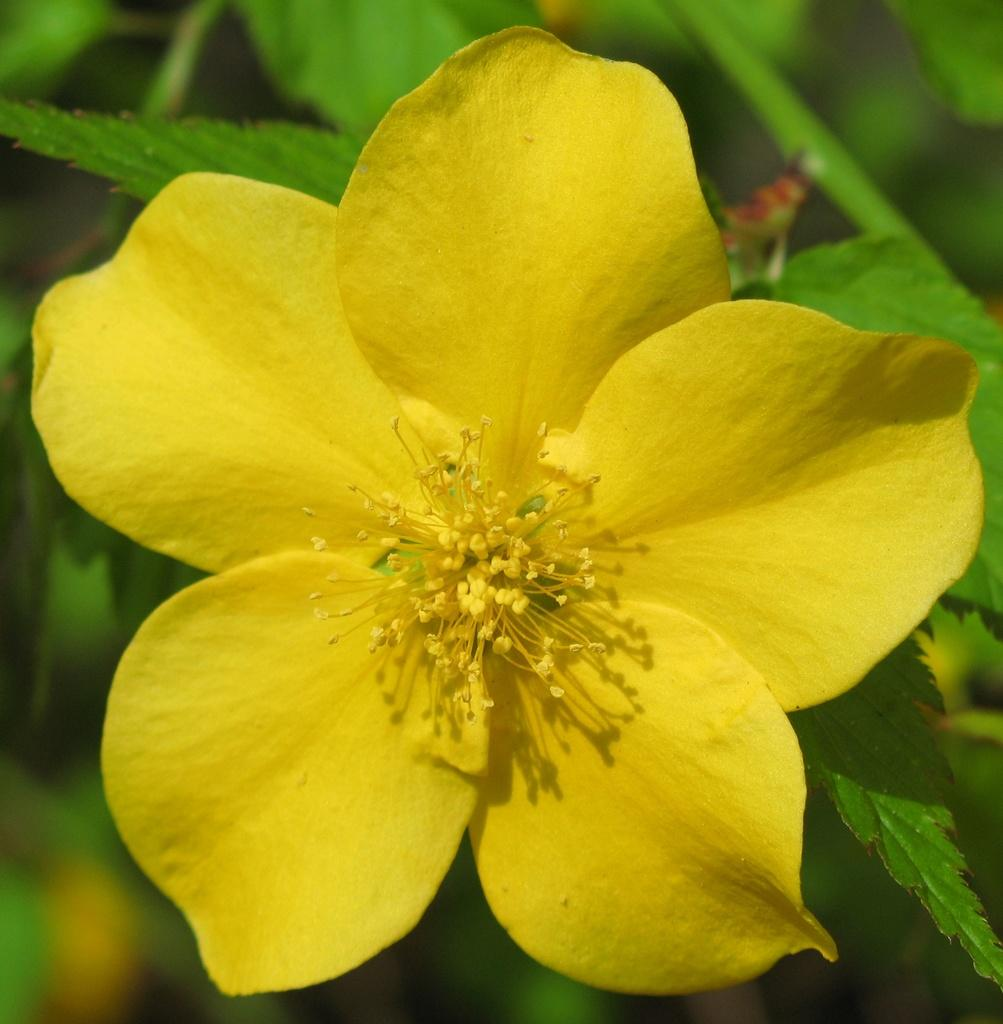What type of flower is in the image? There is a yellow flower in the image. Where is the flower located? The flower is on a plant. Can you describe the background of the image? The background of the image is blurred. How many cherries are hanging from the carriage in the image? There is no carriage or cherries present in the image. What type of ducks can be seen swimming in the background of the image? There are no ducks present in the image; the background is blurred. 